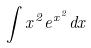Convert formula to latex. <formula><loc_0><loc_0><loc_500><loc_500>\int x ^ { 2 } e ^ { x ^ { 2 } } d x</formula> 